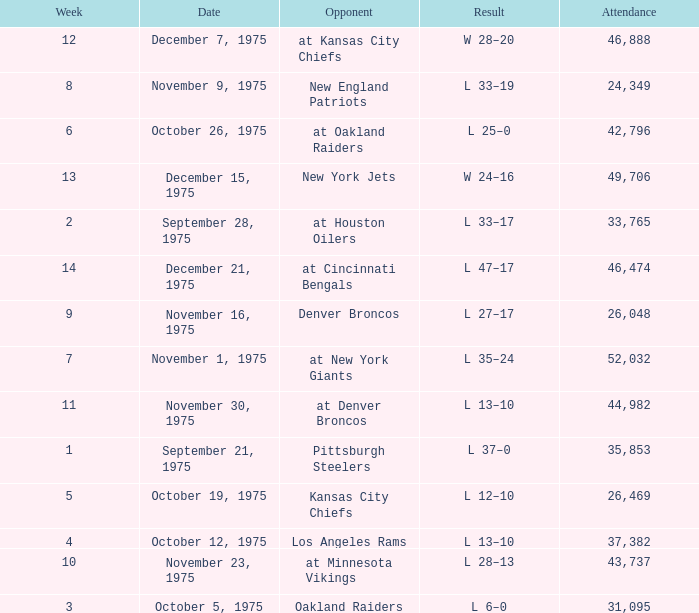What is the highest Week when the opponent was the los angeles rams, with more than 37,382 in Attendance? None. 